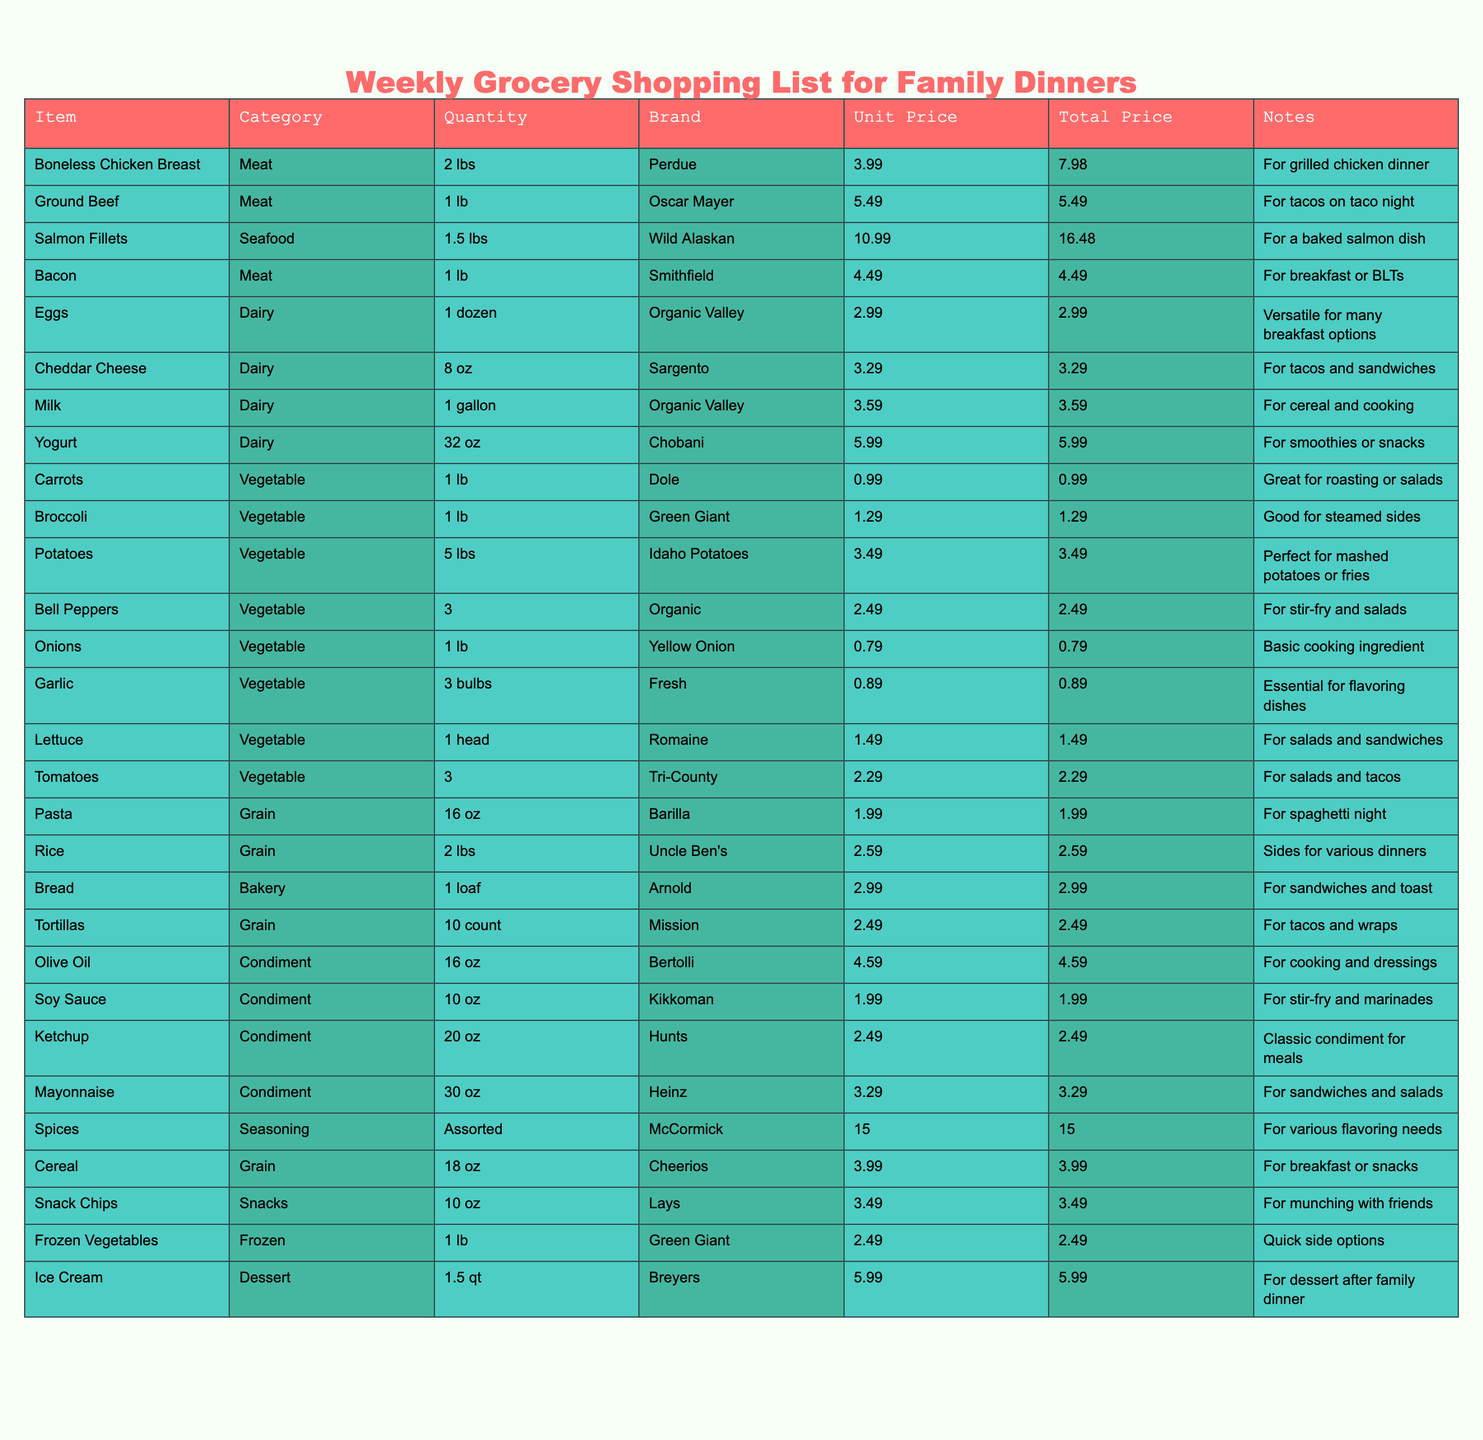What's the total cost of Meat items on the grocery list? Adding the total prices of all meat items: Boneless Chicken Breast (7.98) + Ground Beef (5.49) + Salmon Fillets (16.48) + Bacon (4.49) = 34.44
Answer: 34.44 How many different types of Dairy products are on the list? The Dairy category includes Eggs, Cheddar Cheese, Milk, and Yogurt, which totals four distinct items.
Answer: 4 What is the price of the most expensive item on the list? The most expensive item is Salmon Fillets priced at 16.48, which can be identified by comparing the Total Price of each item.
Answer: 16.48 Is the total quantity of Vegetables greater than the total quantity of Dairy products? The total quantity of Vegetables is 12 lbs (1 lb Carrots + 1 lb Broccoli + 5 lbs Potatoes + 3 Bell Peppers + 1 lb Onions + 3 Tomatoes + 1 lb Lettuce = 12) versus the Dairy total of 1 dozen Eggs + 8 oz Cheese + 1 gallon Milk + 32 oz Yogurt = 1.5 dozen (or 18 oz). Thus, yes, Vegetables are greater.
Answer: Yes What is the average price of all items listed in the Grocery Shopping List? The sum of all Total Prices is 83.56, and there are 30 items total, so the average price is 83.56 / 30 = approximately 2.79.
Answer: 2.79 Which item in the Grain category has the lowest unit price? Examining the unit prices of the Grain items: Pasta (1.99), Rice (2.59), and Tortillas (2.49). The lowest is Pasta at 1.99.
Answer: 1.99 Are there any Snacks listed in the table? Yes, there is one item in the Snacks category, which is Snack Chips. Hence, the answer is yes.
Answer: Yes What is the combined total price of Dairy items? Adding the total prices of Dairy items: Eggs (2.99) + Cheddar Cheese (3.29) + Milk (3.59) + Yogurt (5.99) gives us 15.86 in total.
Answer: 15.86 If I want to make tacos, how much will I spend on ingredients from the list? The ingredients needed are Ground Beef (5.49), Cheddar Cheese (3.29), and Tortillas (2.49). The total is 5.49 + 3.29 + 2.49 = 11.27.
Answer: 11.27 Which category has the highest number of items? Counting the items reveals that the Vegetable category has the most entries with seven items: Carrots, Broccoli, Potatoes, Bell Peppers, Onions, Garlic, and Lettuce.
Answer: Vegetables 